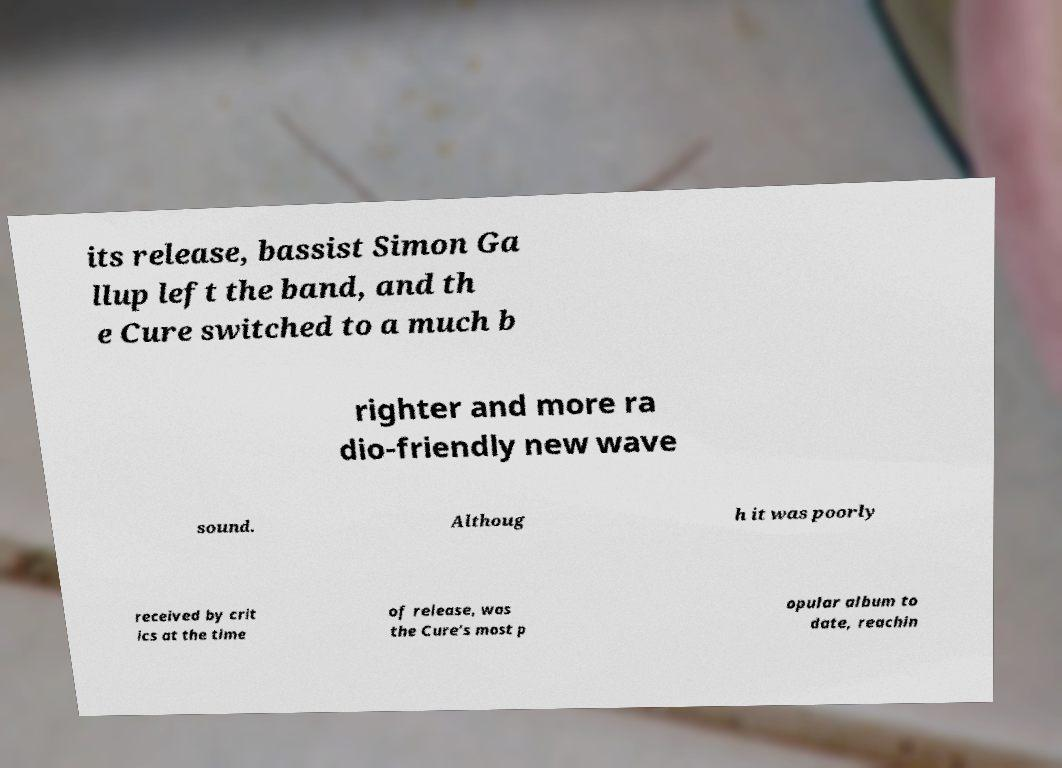Please read and relay the text visible in this image. What does it say? its release, bassist Simon Ga llup left the band, and th e Cure switched to a much b righter and more ra dio-friendly new wave sound. Althoug h it was poorly received by crit ics at the time of release, was the Cure's most p opular album to date, reachin 